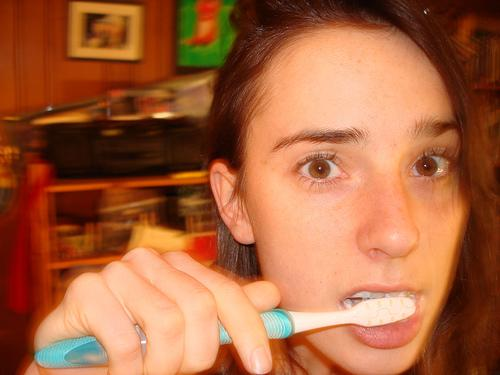Mention the key elements in the picture within a single phrase. Brown-haired woman holding toothbrush with hazel eyes, wooden wall, green painting, and bookshelf. Write a brief description of the photo focusing on the items surrounding the person. A woman holds a toothbrush with both eyes open in front of a wood-paneled wall adorned by a green painting, and there's a bookshelf containing a stereo system nearby. Provide a brief description of the primary focus in the image. A woman with brown hair and eyes is holding a blue and white toothbrush while posing for the indoor photo. List the most significant elements of the image in a single sentence. Oval-faced girl with open hazel eyes, brown hair, toothbrush, wooden wall, green painting, stereo system, and red dress on bookshelf side. Mention the key elements in the picture in one sentence. The photo includes a woman with brown hair, hazel eyes, and an oval face, holding a toothbrush, in front of a brown wooden wall with a green painting. Summarize the main focus of the image and a few other visible details. A girl with an oval face and open hazel eyes holds a toothbrush in front of a wood-paneled wall, which bears a green painting and other displayed items. Provide a concise overview of the image's main subject and background features. A brown-haired girl is holding a toothbrush indoors, against a brown wooden wall that has a green painting, a bookshelf, and a stereo system. Explain the overall scene with particular attention to the background. The image depicts a woman with an indoor background featuring a wood-paneled wall, a green painting of a red fox, a bookshelf with a stereo system, and a red dress hanging on one side. Describe what the woman in the image is doing and her expression. The girl with brown hair and hazel eyes poses in the image while holding a toothbrush with her mouth open, showing her pink lips and white teeth. Describe the person and their action in the photo with emphasis on facial features. A young girl with an oval face, hazel eyes, and brown hair holds a toothbrush with an open mouth, revealing her white teeth and pink lips. 